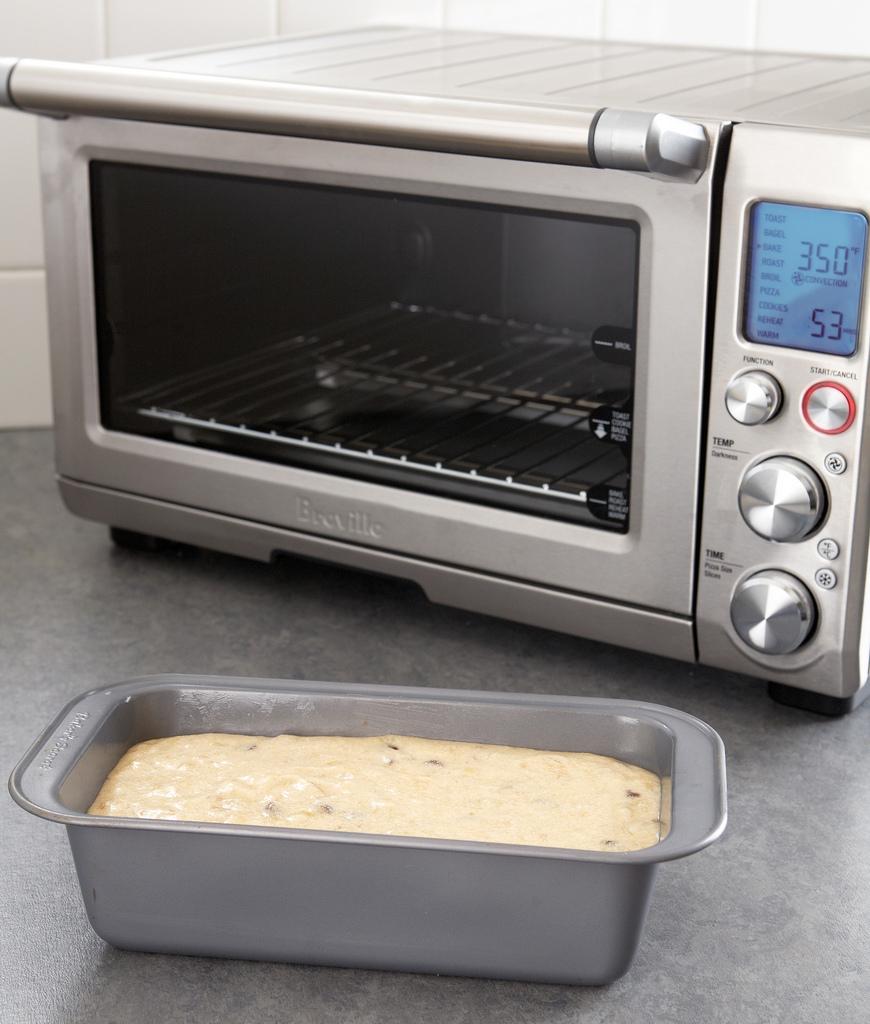What temperature is the oven?
Your answer should be very brief. 350. What is the time on the oven?
Make the answer very short. 53. 